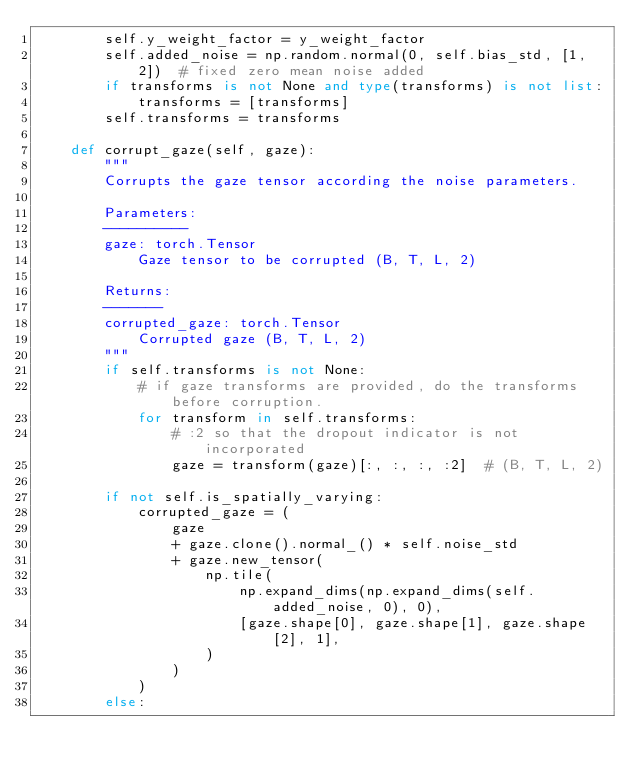<code> <loc_0><loc_0><loc_500><loc_500><_Python_>        self.y_weight_factor = y_weight_factor
        self.added_noise = np.random.normal(0, self.bias_std, [1, 2])  # fixed zero mean noise added
        if transforms is not None and type(transforms) is not list:
            transforms = [transforms]
        self.transforms = transforms

    def corrupt_gaze(self, gaze):
        """
        Corrupts the gaze tensor according the noise parameters.

        Parameters:
        ----------
        gaze: torch.Tensor
            Gaze tensor to be corrupted (B, T, L, 2)

        Returns:
        -------
        corrupted_gaze: torch.Tensor
            Corrupted gaze (B, T, L, 2)
        """
        if self.transforms is not None:
            # if gaze transforms are provided, do the transforms before corruption.
            for transform in self.transforms:
                # :2 so that the dropout indicator is not incorporated
                gaze = transform(gaze)[:, :, :, :2]  # (B, T, L, 2)

        if not self.is_spatially_varying:
            corrupted_gaze = (
                gaze
                + gaze.clone().normal_() * self.noise_std
                + gaze.new_tensor(
                    np.tile(
                        np.expand_dims(np.expand_dims(self.added_noise, 0), 0),
                        [gaze.shape[0], gaze.shape[1], gaze.shape[2], 1],
                    )
                )
            )
        else:</code> 